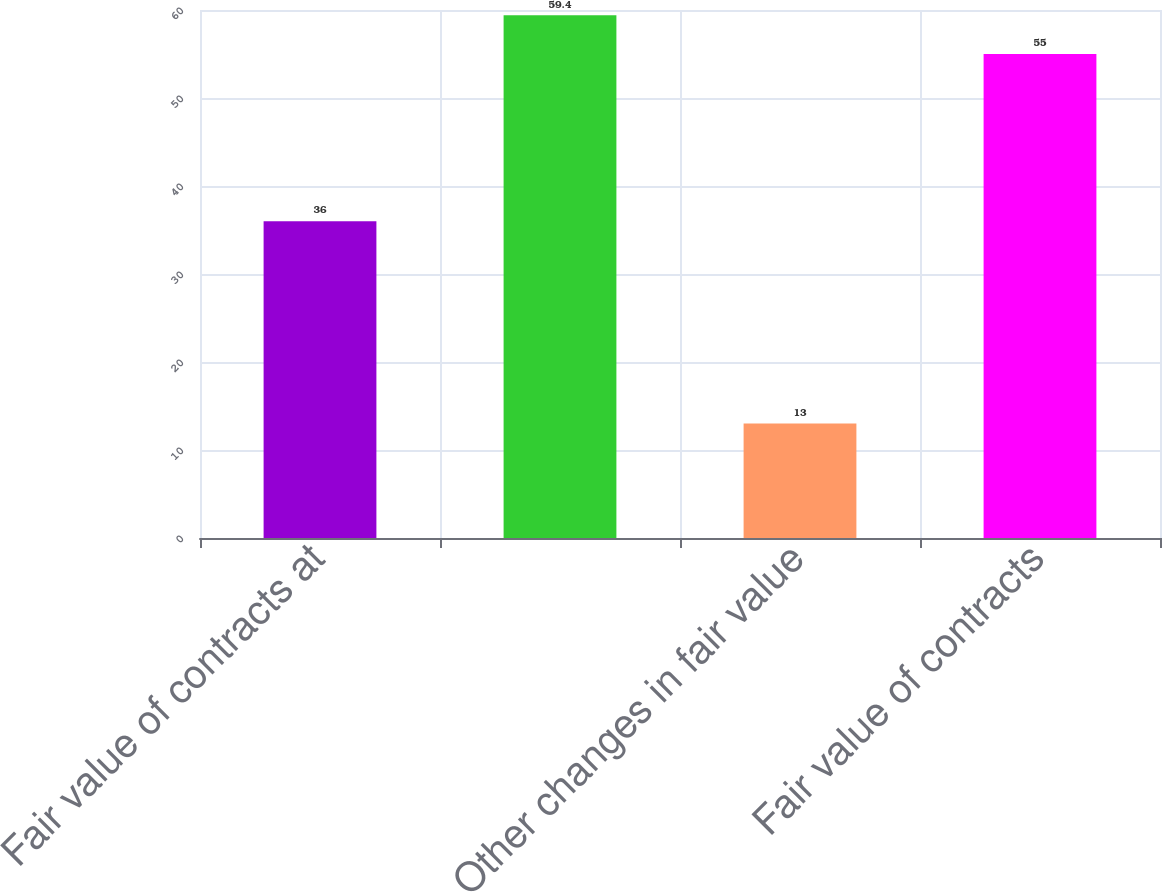<chart> <loc_0><loc_0><loc_500><loc_500><bar_chart><fcel>Fair value of contracts at<fcel>Unnamed: 1<fcel>Other changes in fair value<fcel>Fair value of contracts<nl><fcel>36<fcel>59.4<fcel>13<fcel>55<nl></chart> 